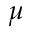Convert formula to latex. <formula><loc_0><loc_0><loc_500><loc_500>\mu</formula> 